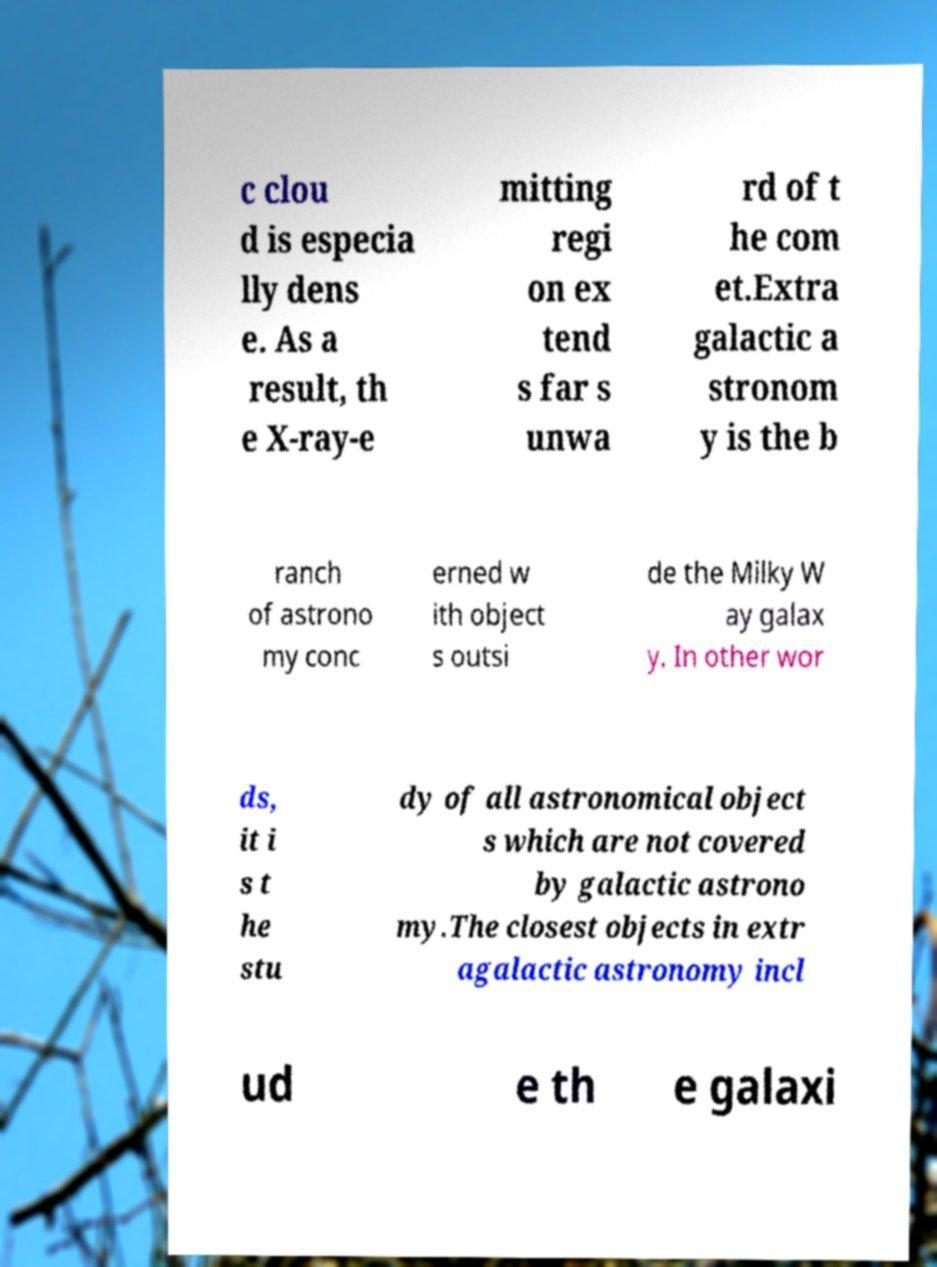I need the written content from this picture converted into text. Can you do that? c clou d is especia lly dens e. As a result, th e X-ray-e mitting regi on ex tend s far s unwa rd of t he com et.Extra galactic a stronom y is the b ranch of astrono my conc erned w ith object s outsi de the Milky W ay galax y. In other wor ds, it i s t he stu dy of all astronomical object s which are not covered by galactic astrono my.The closest objects in extr agalactic astronomy incl ud e th e galaxi 